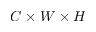Convert formula to latex. <formula><loc_0><loc_0><loc_500><loc_500>C \times W \times H</formula> 